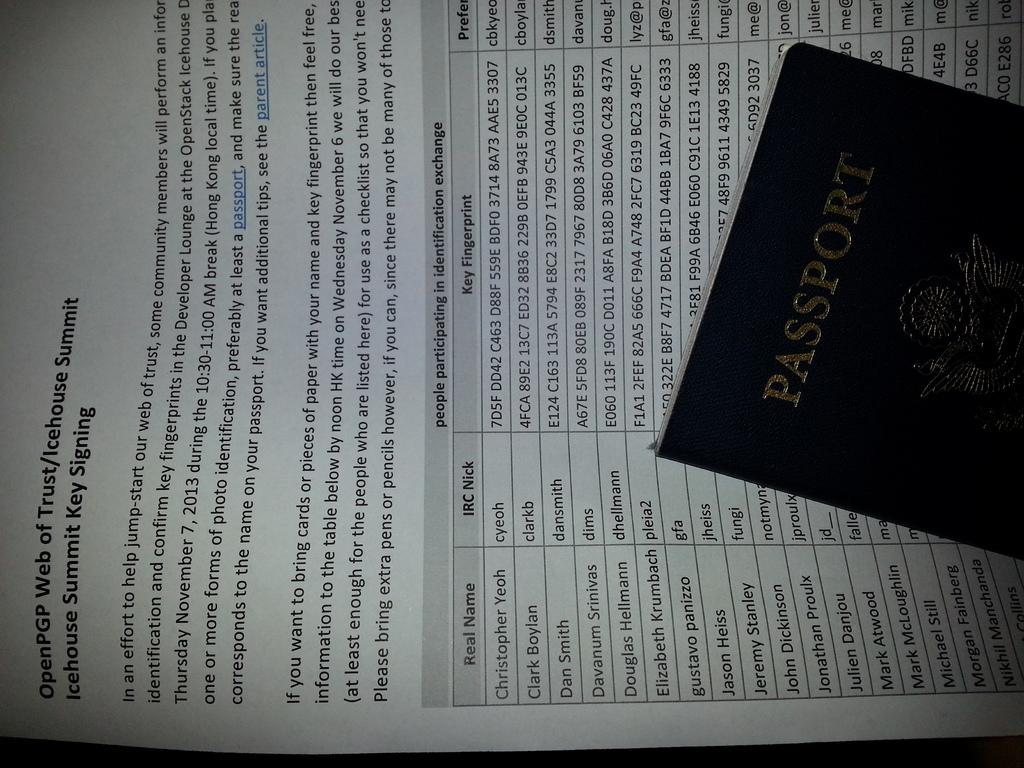Provide a one-sentence caption for the provided image. A passport lays on top of a piece of paper about a summit. 